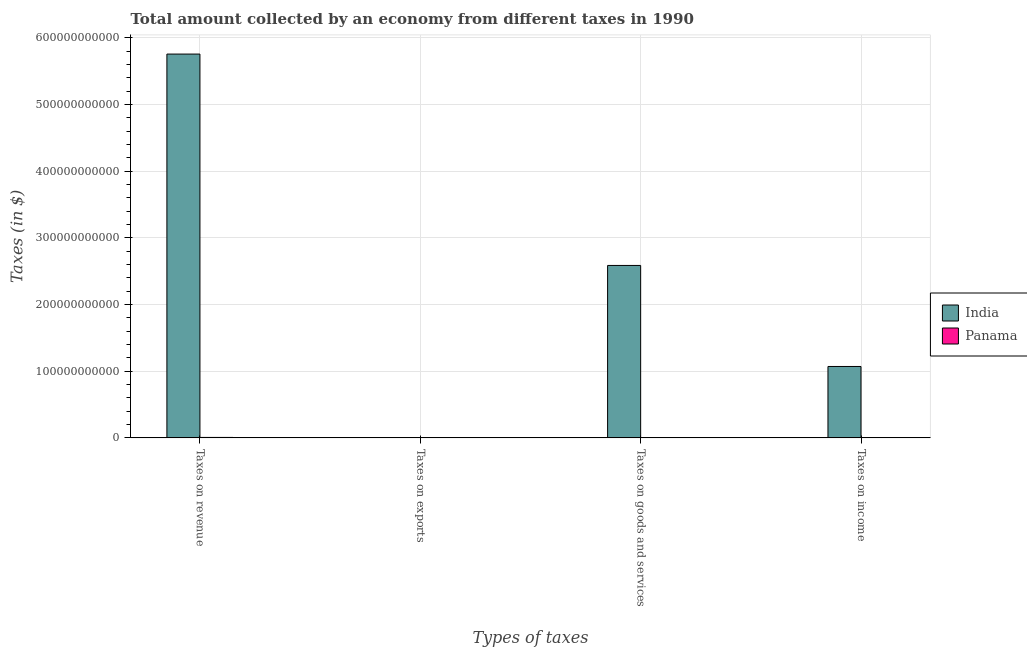How many different coloured bars are there?
Give a very brief answer. 2. Are the number of bars per tick equal to the number of legend labels?
Your answer should be very brief. Yes. Are the number of bars on each tick of the X-axis equal?
Provide a short and direct response. Yes. What is the label of the 4th group of bars from the left?
Provide a short and direct response. Taxes on income. What is the amount collected as tax on goods in Panama?
Provide a succinct answer. 2.33e+08. Across all countries, what is the maximum amount collected as tax on goods?
Provide a short and direct response. 2.59e+11. Across all countries, what is the minimum amount collected as tax on income?
Make the answer very short. 2.29e+08. In which country was the amount collected as tax on income maximum?
Your response must be concise. India. In which country was the amount collected as tax on exports minimum?
Keep it short and to the point. Panama. What is the total amount collected as tax on exports in the graph?
Ensure brevity in your answer.  3.73e+08. What is the difference between the amount collected as tax on revenue in Panama and that in India?
Give a very brief answer. -5.75e+11. What is the difference between the amount collected as tax on exports in Panama and the amount collected as tax on revenue in India?
Make the answer very short. -5.76e+11. What is the average amount collected as tax on exports per country?
Offer a very short reply. 1.86e+08. What is the difference between the amount collected as tax on goods and amount collected as tax on income in India?
Your answer should be compact. 1.52e+11. In how many countries, is the amount collected as tax on goods greater than 320000000000 $?
Make the answer very short. 0. What is the ratio of the amount collected as tax on revenue in Panama to that in India?
Make the answer very short. 0. Is the amount collected as tax on exports in India less than that in Panama?
Ensure brevity in your answer.  No. What is the difference between the highest and the second highest amount collected as tax on goods?
Give a very brief answer. 2.58e+11. What is the difference between the highest and the lowest amount collected as tax on revenue?
Your answer should be very brief. 5.75e+11. Is the sum of the amount collected as tax on revenue in Panama and India greater than the maximum amount collected as tax on goods across all countries?
Provide a short and direct response. Yes. Is it the case that in every country, the sum of the amount collected as tax on goods and amount collected as tax on exports is greater than the sum of amount collected as tax on revenue and amount collected as tax on income?
Keep it short and to the point. No. What does the 2nd bar from the right in Taxes on revenue represents?
Your answer should be compact. India. Is it the case that in every country, the sum of the amount collected as tax on revenue and amount collected as tax on exports is greater than the amount collected as tax on goods?
Your answer should be very brief. Yes. Are all the bars in the graph horizontal?
Provide a succinct answer. No. What is the difference between two consecutive major ticks on the Y-axis?
Provide a short and direct response. 1.00e+11. Does the graph contain grids?
Your answer should be very brief. Yes. What is the title of the graph?
Your answer should be very brief. Total amount collected by an economy from different taxes in 1990. Does "Latin America(developing only)" appear as one of the legend labels in the graph?
Provide a succinct answer. No. What is the label or title of the X-axis?
Ensure brevity in your answer.  Types of taxes. What is the label or title of the Y-axis?
Your answer should be compact. Taxes (in $). What is the Taxes (in $) in India in Taxes on revenue?
Your answer should be compact. 5.76e+11. What is the Taxes (in $) of Panama in Taxes on revenue?
Make the answer very short. 6.70e+08. What is the Taxes (in $) of India in Taxes on exports?
Make the answer very short. 3.60e+08. What is the Taxes (in $) in Panama in Taxes on exports?
Make the answer very short. 1.26e+07. What is the Taxes (in $) in India in Taxes on goods and services?
Your answer should be very brief. 2.59e+11. What is the Taxes (in $) in Panama in Taxes on goods and services?
Make the answer very short. 2.33e+08. What is the Taxes (in $) of India in Taxes on income?
Offer a terse response. 1.07e+11. What is the Taxes (in $) of Panama in Taxes on income?
Give a very brief answer. 2.29e+08. Across all Types of taxes, what is the maximum Taxes (in $) of India?
Your answer should be very brief. 5.76e+11. Across all Types of taxes, what is the maximum Taxes (in $) of Panama?
Offer a very short reply. 6.70e+08. Across all Types of taxes, what is the minimum Taxes (in $) in India?
Give a very brief answer. 3.60e+08. Across all Types of taxes, what is the minimum Taxes (in $) in Panama?
Ensure brevity in your answer.  1.26e+07. What is the total Taxes (in $) of India in the graph?
Offer a very short reply. 9.42e+11. What is the total Taxes (in $) in Panama in the graph?
Provide a succinct answer. 1.14e+09. What is the difference between the Taxes (in $) in India in Taxes on revenue and that in Taxes on exports?
Keep it short and to the point. 5.75e+11. What is the difference between the Taxes (in $) of Panama in Taxes on revenue and that in Taxes on exports?
Provide a succinct answer. 6.57e+08. What is the difference between the Taxes (in $) in India in Taxes on revenue and that in Taxes on goods and services?
Offer a terse response. 3.17e+11. What is the difference between the Taxes (in $) of Panama in Taxes on revenue and that in Taxes on goods and services?
Your answer should be very brief. 4.37e+08. What is the difference between the Taxes (in $) of India in Taxes on revenue and that in Taxes on income?
Provide a succinct answer. 4.69e+11. What is the difference between the Taxes (in $) of Panama in Taxes on revenue and that in Taxes on income?
Provide a succinct answer. 4.41e+08. What is the difference between the Taxes (in $) in India in Taxes on exports and that in Taxes on goods and services?
Ensure brevity in your answer.  -2.58e+11. What is the difference between the Taxes (in $) in Panama in Taxes on exports and that in Taxes on goods and services?
Your answer should be compact. -2.20e+08. What is the difference between the Taxes (in $) in India in Taxes on exports and that in Taxes on income?
Your answer should be very brief. -1.07e+11. What is the difference between the Taxes (in $) in Panama in Taxes on exports and that in Taxes on income?
Keep it short and to the point. -2.17e+08. What is the difference between the Taxes (in $) of India in Taxes on goods and services and that in Taxes on income?
Provide a succinct answer. 1.52e+11. What is the difference between the Taxes (in $) of Panama in Taxes on goods and services and that in Taxes on income?
Provide a short and direct response. 3.20e+06. What is the difference between the Taxes (in $) of India in Taxes on revenue and the Taxes (in $) of Panama in Taxes on exports?
Provide a succinct answer. 5.76e+11. What is the difference between the Taxes (in $) of India in Taxes on revenue and the Taxes (in $) of Panama in Taxes on goods and services?
Offer a very short reply. 5.76e+11. What is the difference between the Taxes (in $) of India in Taxes on revenue and the Taxes (in $) of Panama in Taxes on income?
Give a very brief answer. 5.76e+11. What is the difference between the Taxes (in $) in India in Taxes on exports and the Taxes (in $) in Panama in Taxes on goods and services?
Provide a short and direct response. 1.27e+08. What is the difference between the Taxes (in $) in India in Taxes on exports and the Taxes (in $) in Panama in Taxes on income?
Make the answer very short. 1.31e+08. What is the difference between the Taxes (in $) of India in Taxes on goods and services and the Taxes (in $) of Panama in Taxes on income?
Your response must be concise. 2.58e+11. What is the average Taxes (in $) of India per Types of taxes?
Your answer should be compact. 2.35e+11. What is the average Taxes (in $) of Panama per Types of taxes?
Provide a succinct answer. 2.86e+08. What is the difference between the Taxes (in $) in India and Taxes (in $) in Panama in Taxes on revenue?
Give a very brief answer. 5.75e+11. What is the difference between the Taxes (in $) in India and Taxes (in $) in Panama in Taxes on exports?
Your answer should be compact. 3.47e+08. What is the difference between the Taxes (in $) in India and Taxes (in $) in Panama in Taxes on goods and services?
Provide a short and direct response. 2.58e+11. What is the difference between the Taxes (in $) in India and Taxes (in $) in Panama in Taxes on income?
Ensure brevity in your answer.  1.07e+11. What is the ratio of the Taxes (in $) of India in Taxes on revenue to that in Taxes on exports?
Give a very brief answer. 1599.28. What is the ratio of the Taxes (in $) of Panama in Taxes on revenue to that in Taxes on exports?
Your answer should be compact. 53.17. What is the ratio of the Taxes (in $) in India in Taxes on revenue to that in Taxes on goods and services?
Your response must be concise. 2.23. What is the ratio of the Taxes (in $) of Panama in Taxes on revenue to that in Taxes on goods and services?
Offer a terse response. 2.88. What is the ratio of the Taxes (in $) of India in Taxes on revenue to that in Taxes on income?
Give a very brief answer. 5.38. What is the ratio of the Taxes (in $) of Panama in Taxes on revenue to that in Taxes on income?
Offer a very short reply. 2.92. What is the ratio of the Taxes (in $) in India in Taxes on exports to that in Taxes on goods and services?
Provide a succinct answer. 0. What is the ratio of the Taxes (in $) of Panama in Taxes on exports to that in Taxes on goods and services?
Give a very brief answer. 0.05. What is the ratio of the Taxes (in $) of India in Taxes on exports to that in Taxes on income?
Your response must be concise. 0. What is the ratio of the Taxes (in $) in Panama in Taxes on exports to that in Taxes on income?
Your answer should be compact. 0.05. What is the ratio of the Taxes (in $) of India in Taxes on goods and services to that in Taxes on income?
Provide a succinct answer. 2.42. What is the ratio of the Taxes (in $) of Panama in Taxes on goods and services to that in Taxes on income?
Offer a very short reply. 1.01. What is the difference between the highest and the second highest Taxes (in $) in India?
Offer a very short reply. 3.17e+11. What is the difference between the highest and the second highest Taxes (in $) in Panama?
Provide a short and direct response. 4.37e+08. What is the difference between the highest and the lowest Taxes (in $) in India?
Give a very brief answer. 5.75e+11. What is the difference between the highest and the lowest Taxes (in $) of Panama?
Provide a succinct answer. 6.57e+08. 